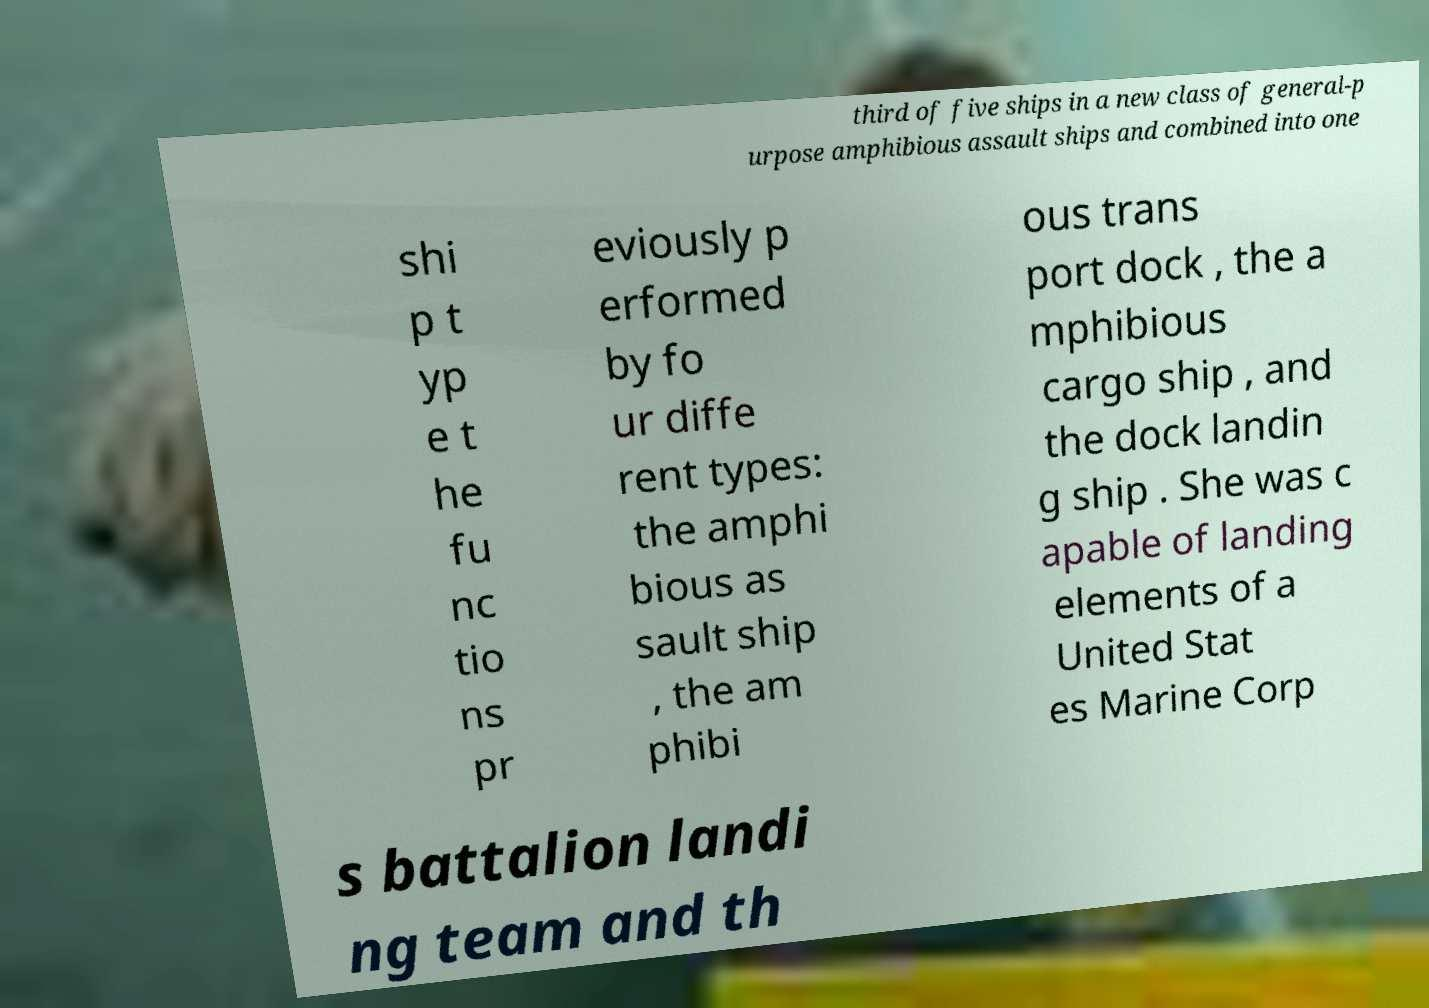Please identify and transcribe the text found in this image. third of five ships in a new class of general-p urpose amphibious assault ships and combined into one shi p t yp e t he fu nc tio ns pr eviously p erformed by fo ur diffe rent types: the amphi bious as sault ship , the am phibi ous trans port dock , the a mphibious cargo ship , and the dock landin g ship . She was c apable of landing elements of a United Stat es Marine Corp s battalion landi ng team and th 